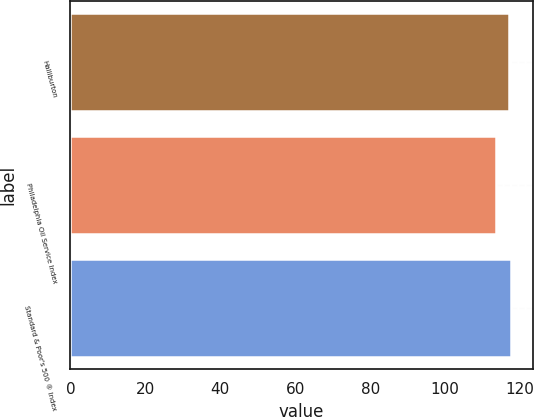<chart> <loc_0><loc_0><loc_500><loc_500><bar_chart><fcel>Halliburton<fcel>Philadelphia Oil Service Index<fcel>Standard & Poor's 500 ® Index<nl><fcel>117.09<fcel>113.53<fcel>117.49<nl></chart> 